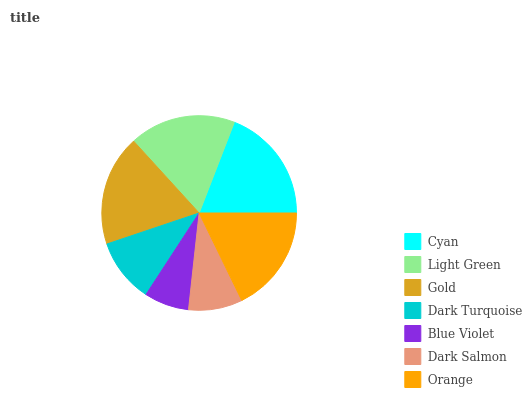Is Blue Violet the minimum?
Answer yes or no. Yes. Is Cyan the maximum?
Answer yes or no. Yes. Is Light Green the minimum?
Answer yes or no. No. Is Light Green the maximum?
Answer yes or no. No. Is Cyan greater than Light Green?
Answer yes or no. Yes. Is Light Green less than Cyan?
Answer yes or no. Yes. Is Light Green greater than Cyan?
Answer yes or no. No. Is Cyan less than Light Green?
Answer yes or no. No. Is Light Green the high median?
Answer yes or no. Yes. Is Light Green the low median?
Answer yes or no. Yes. Is Gold the high median?
Answer yes or no. No. Is Gold the low median?
Answer yes or no. No. 